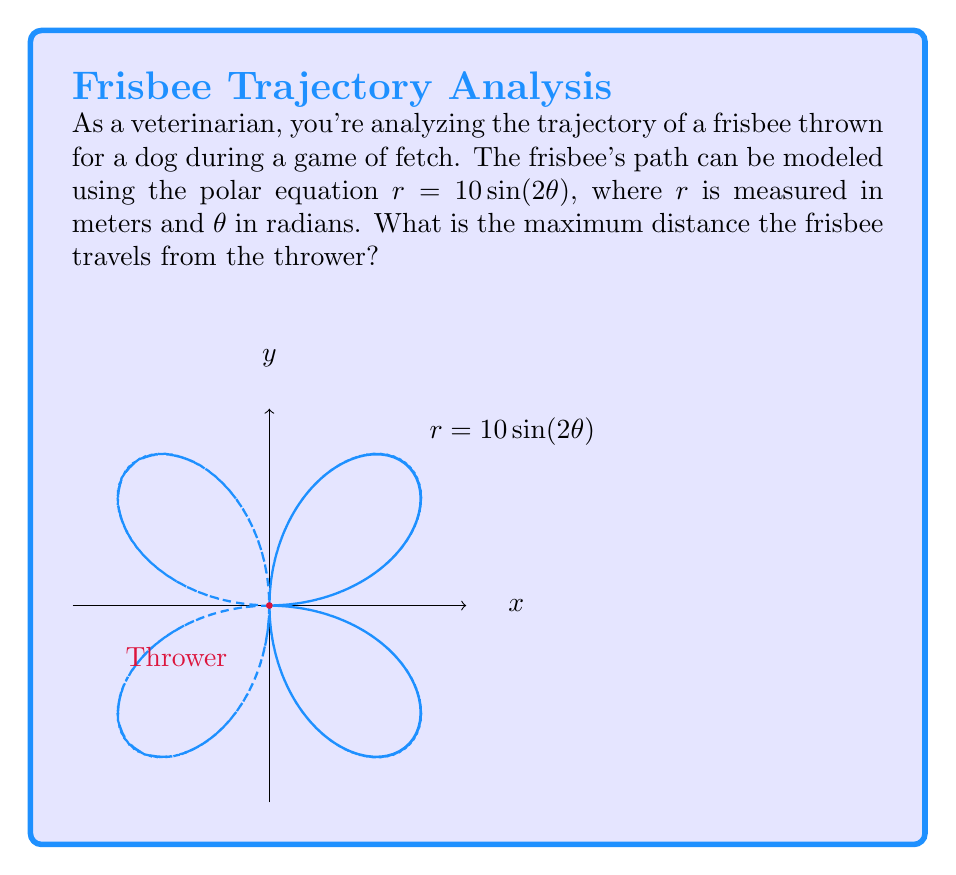Can you solve this math problem? Let's approach this step-by-step:

1) The maximum distance will occur when $r$ is at its maximum value.

2) In the equation $r = 10\sin(2\theta)$, the maximum value of $r$ will occur when $\sin(2\theta)$ is at its maximum.

3) We know that the maximum value of sine is 1, which occurs when its argument is $\frac{\pi}{2}$ (or odd multiples of $\frac{\pi}{2}$).

4) So, we need to solve:
   $2\theta = \frac{\pi}{2}$
   $\theta = \frac{\pi}{4}$

5) This means the maximum distance occurs when $\theta = \frac{\pi}{4}$ (and also at $\frac{3\pi}{4}$ due to the symmetry of the sine function).

6) To find the maximum distance, we substitute this value of $\theta$ back into our original equation:

   $r = 10\sin(2 \cdot \frac{\pi}{4})$
   $r = 10\sin(\frac{\pi}{2})$
   $r = 10 \cdot 1 = 10$

Therefore, the maximum distance the frisbee travels from the thrower is 10 meters.
Answer: 10 meters 